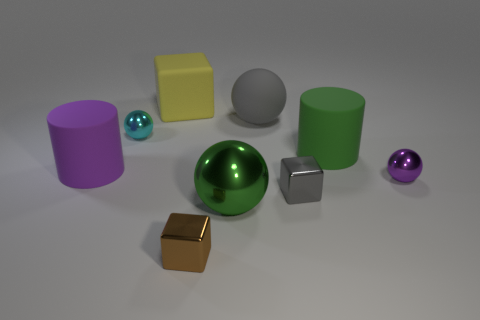Is there anything else of the same color as the big rubber block?
Offer a very short reply. No. Are there fewer small metallic balls that are left of the big block than brown metal things?
Offer a very short reply. No. Are there more purple metallic spheres than tiny objects?
Make the answer very short. No. There is a large green thing in front of the purple thing to the right of the tiny gray metal thing; are there any gray blocks behind it?
Your answer should be compact. Yes. What number of other things are the same size as the brown thing?
Keep it short and to the point. 3. There is a large purple thing; are there any large green cylinders behind it?
Ensure brevity in your answer.  Yes. There is a large metallic sphere; does it have the same color as the cylinder that is left of the yellow matte block?
Provide a succinct answer. No. What is the color of the metallic object in front of the green object in front of the cylinder to the right of the yellow matte cube?
Make the answer very short. Brown. Are there any small purple shiny things that have the same shape as the tiny brown shiny thing?
Make the answer very short. No. The rubber sphere that is the same size as the yellow block is what color?
Provide a succinct answer. Gray. 